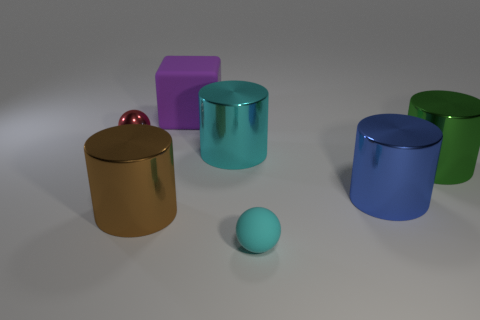Subtract 2 cylinders. How many cylinders are left? 2 Subtract all blue metal cylinders. How many cylinders are left? 3 Subtract all blue cylinders. How many cylinders are left? 3 Add 2 red metal balls. How many objects exist? 9 Subtract all red cylinders. Subtract all purple blocks. How many cylinders are left? 4 Subtract all cubes. How many objects are left? 6 Subtract all small gray matte cylinders. Subtract all tiny cyan balls. How many objects are left? 6 Add 3 blue cylinders. How many blue cylinders are left? 4 Add 1 tiny green matte cubes. How many tiny green matte cubes exist? 1 Subtract 0 red cubes. How many objects are left? 7 